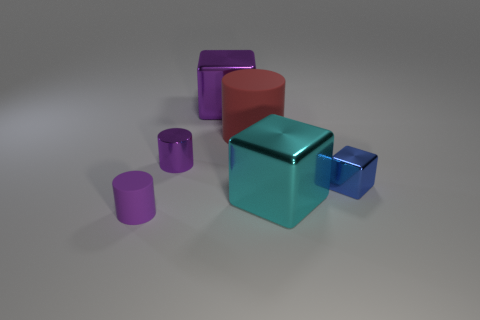What could be a possible use for the cyan cube in a real-world setting? In a real-world setting, the cyan cube, with its metallic finish, could be envisaged as a modernist aesthetic piece in interior design or as a conceptual art object that plays with geometry and color in space.  Could you tell me how the size of the objects might represent their importance in the composition? The size of the objects could be intentionally varied to draw attention to certain elements over others. Larger objects tend to dominate compositions, suggesting significance, whereas smaller objects might play supporting roles or create a sense of scale and perspective. 